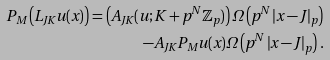Convert formula to latex. <formula><loc_0><loc_0><loc_500><loc_500>P _ { M } \left ( L _ { J K } u ( x ) \right ) = \left ( A _ { J K } ( u ; K + p ^ { N } \mathbb { Z } _ { p } ) \right ) \Omega \left ( p ^ { N } \left | x - J \right | _ { p } \right ) \\ - A _ { J K } P _ { M } u ( x ) \Omega \left ( p ^ { N } \left | x - J \right | _ { p } \right ) .</formula> 